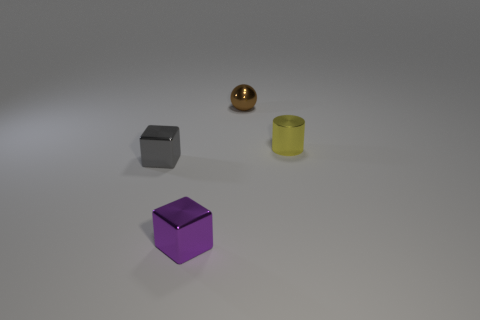Subtract all purple cubes. How many cubes are left? 1 Subtract 1 cylinders. How many cylinders are left? 0 Add 3 large brown cubes. How many objects exist? 7 Subtract all spheres. How many objects are left? 3 Subtract all gray cylinders. Subtract all tiny metal things. How many objects are left? 0 Add 1 tiny gray shiny objects. How many tiny gray shiny objects are left? 2 Add 1 large green things. How many large green things exist? 1 Subtract 1 yellow cylinders. How many objects are left? 3 Subtract all blue balls. Subtract all gray cubes. How many balls are left? 1 